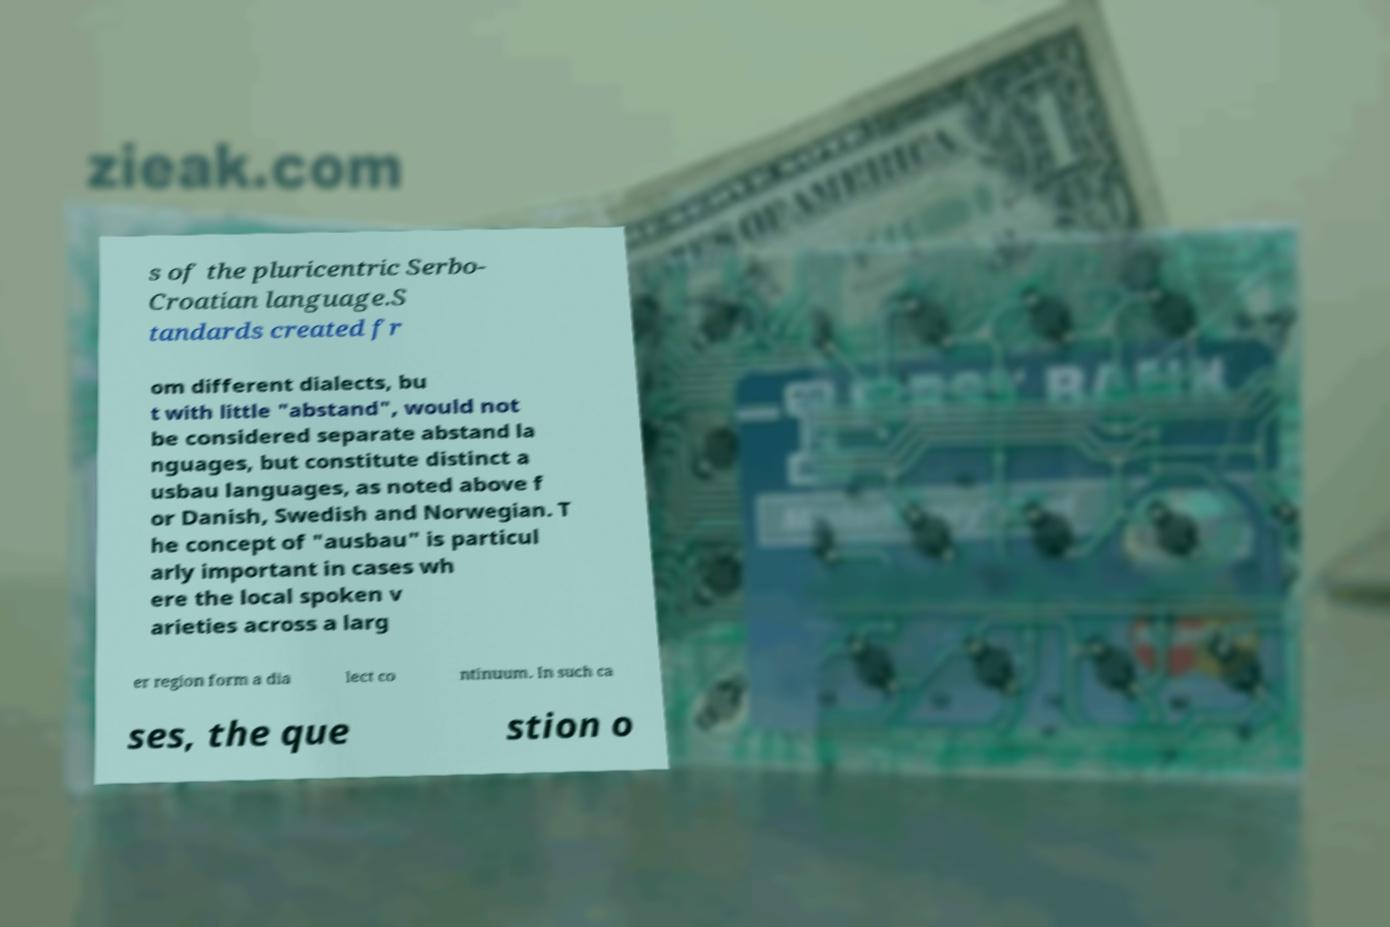Please read and relay the text visible in this image. What does it say? s of the pluricentric Serbo- Croatian language.S tandards created fr om different dialects, bu t with little "abstand", would not be considered separate abstand la nguages, but constitute distinct a usbau languages, as noted above f or Danish, Swedish and Norwegian. T he concept of "ausbau" is particul arly important in cases wh ere the local spoken v arieties across a larg er region form a dia lect co ntinuum. In such ca ses, the que stion o 